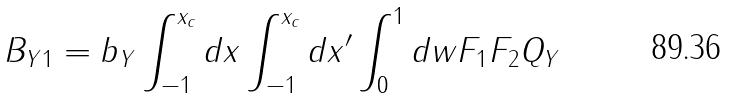Convert formula to latex. <formula><loc_0><loc_0><loc_500><loc_500>B _ { Y 1 } = b _ { Y } \int _ { - 1 } ^ { x _ { c } } d x \int _ { - 1 } ^ { x _ { c } } d x ^ { \prime } \int _ { 0 } ^ { 1 } d w F _ { 1 } F _ { 2 } Q _ { Y }</formula> 